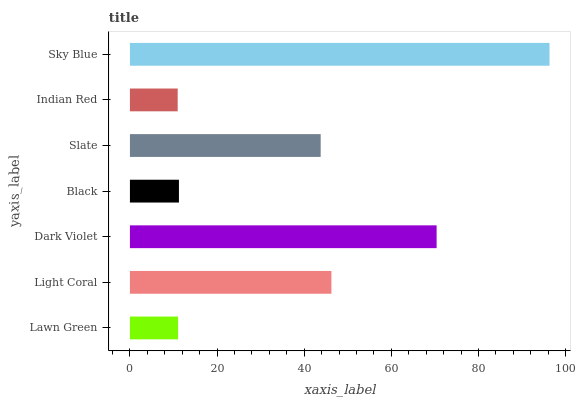Is Indian Red the minimum?
Answer yes or no. Yes. Is Sky Blue the maximum?
Answer yes or no. Yes. Is Light Coral the minimum?
Answer yes or no. No. Is Light Coral the maximum?
Answer yes or no. No. Is Light Coral greater than Lawn Green?
Answer yes or no. Yes. Is Lawn Green less than Light Coral?
Answer yes or no. Yes. Is Lawn Green greater than Light Coral?
Answer yes or no. No. Is Light Coral less than Lawn Green?
Answer yes or no. No. Is Slate the high median?
Answer yes or no. Yes. Is Slate the low median?
Answer yes or no. Yes. Is Indian Red the high median?
Answer yes or no. No. Is Sky Blue the low median?
Answer yes or no. No. 